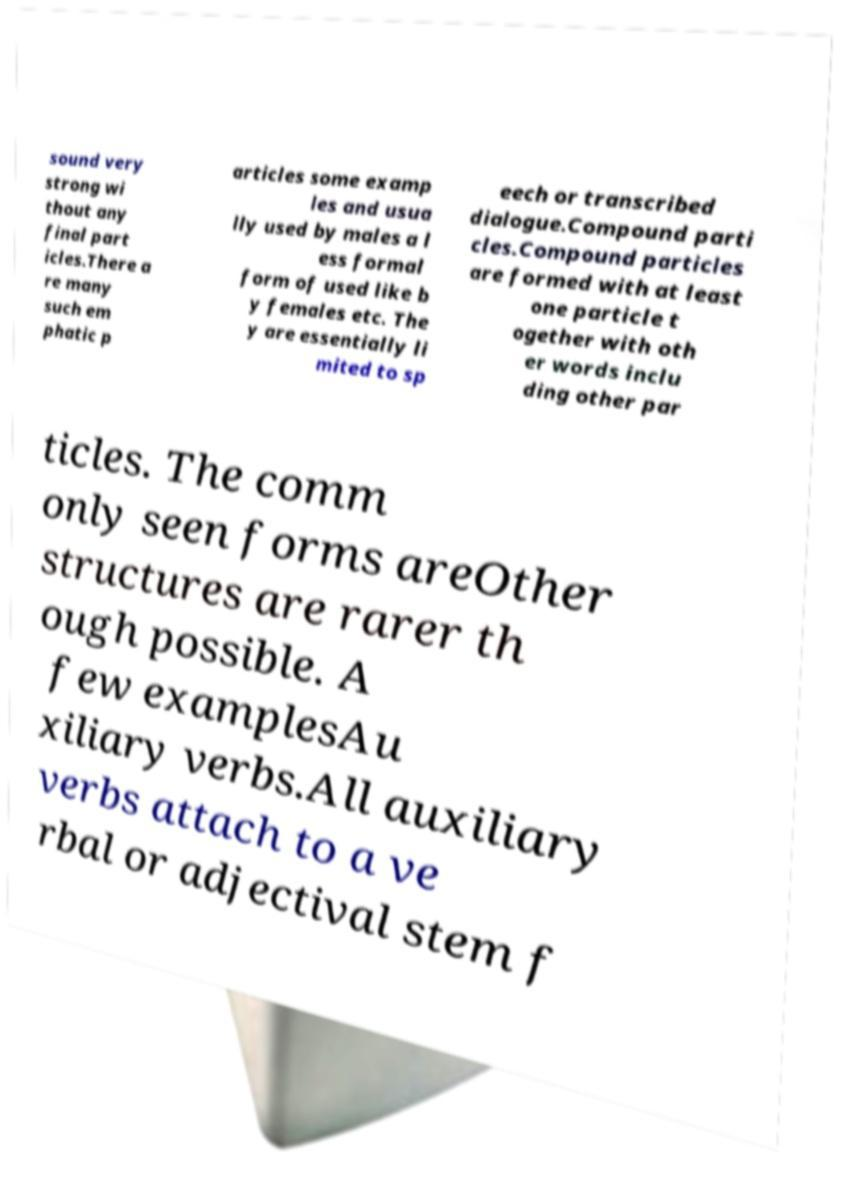Please identify and transcribe the text found in this image. sound very strong wi thout any final part icles.There a re many such em phatic p articles some examp les and usua lly used by males a l ess formal form of used like b y females etc. The y are essentially li mited to sp eech or transcribed dialogue.Compound parti cles.Compound particles are formed with at least one particle t ogether with oth er words inclu ding other par ticles. The comm only seen forms areOther structures are rarer th ough possible. A few examplesAu xiliary verbs.All auxiliary verbs attach to a ve rbal or adjectival stem f 